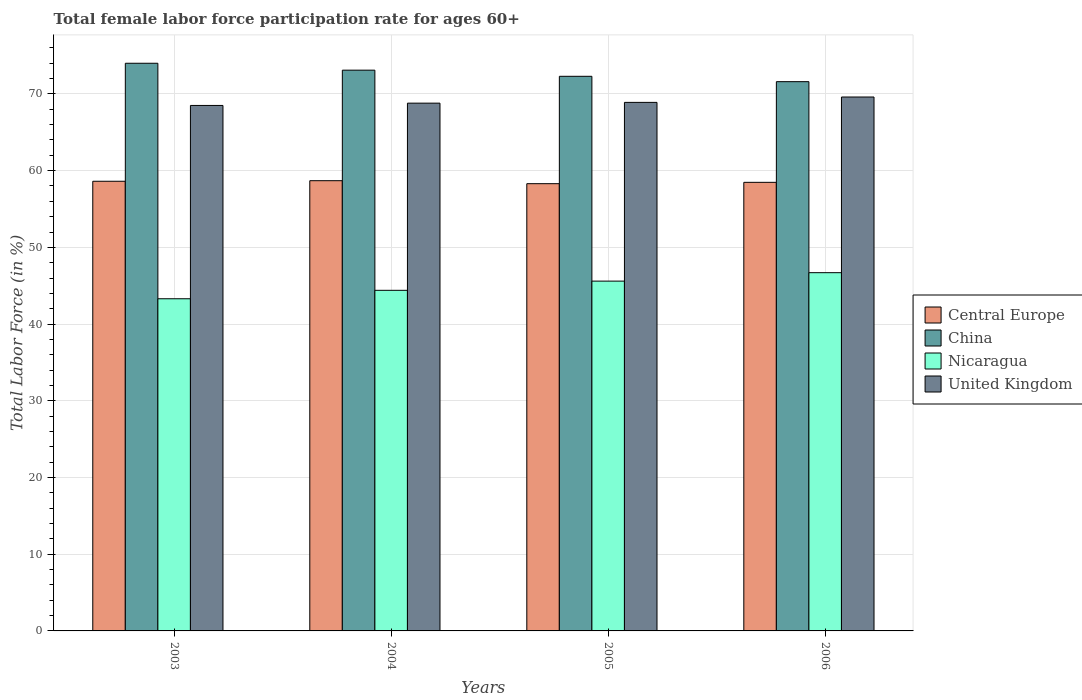How many bars are there on the 2nd tick from the left?
Keep it short and to the point. 4. How many bars are there on the 2nd tick from the right?
Provide a short and direct response. 4. In how many cases, is the number of bars for a given year not equal to the number of legend labels?
Your answer should be very brief. 0. What is the female labor force participation rate in Central Europe in 2004?
Keep it short and to the point. 58.69. Across all years, what is the maximum female labor force participation rate in United Kingdom?
Give a very brief answer. 69.6. Across all years, what is the minimum female labor force participation rate in China?
Offer a very short reply. 71.6. What is the total female labor force participation rate in Central Europe in the graph?
Make the answer very short. 234.09. What is the difference between the female labor force participation rate in United Kingdom in 2003 and that in 2005?
Make the answer very short. -0.4. What is the difference between the female labor force participation rate in Nicaragua in 2003 and the female labor force participation rate in China in 2006?
Ensure brevity in your answer.  -28.3. What is the average female labor force participation rate in Central Europe per year?
Provide a succinct answer. 58.52. In the year 2003, what is the difference between the female labor force participation rate in Central Europe and female labor force participation rate in Nicaragua?
Make the answer very short. 15.32. In how many years, is the female labor force participation rate in China greater than 66 %?
Ensure brevity in your answer.  4. What is the ratio of the female labor force participation rate in Nicaragua in 2004 to that in 2005?
Offer a very short reply. 0.97. Is the difference between the female labor force participation rate in Central Europe in 2005 and 2006 greater than the difference between the female labor force participation rate in Nicaragua in 2005 and 2006?
Give a very brief answer. Yes. What is the difference between the highest and the second highest female labor force participation rate in Central Europe?
Provide a short and direct response. 0.07. What is the difference between the highest and the lowest female labor force participation rate in Nicaragua?
Offer a terse response. 3.4. In how many years, is the female labor force participation rate in Nicaragua greater than the average female labor force participation rate in Nicaragua taken over all years?
Make the answer very short. 2. Is the sum of the female labor force participation rate in United Kingdom in 2003 and 2004 greater than the maximum female labor force participation rate in China across all years?
Keep it short and to the point. Yes. Is it the case that in every year, the sum of the female labor force participation rate in United Kingdom and female labor force participation rate in China is greater than the sum of female labor force participation rate in Nicaragua and female labor force participation rate in Central Europe?
Give a very brief answer. Yes. What does the 2nd bar from the right in 2005 represents?
Your answer should be very brief. Nicaragua. How many bars are there?
Give a very brief answer. 16. Are all the bars in the graph horizontal?
Your answer should be compact. No. How many years are there in the graph?
Your answer should be very brief. 4. Does the graph contain grids?
Make the answer very short. Yes. How many legend labels are there?
Offer a terse response. 4. What is the title of the graph?
Provide a short and direct response. Total female labor force participation rate for ages 60+. What is the label or title of the Y-axis?
Give a very brief answer. Total Labor Force (in %). What is the Total Labor Force (in %) of Central Europe in 2003?
Your answer should be compact. 58.62. What is the Total Labor Force (in %) in China in 2003?
Make the answer very short. 74. What is the Total Labor Force (in %) in Nicaragua in 2003?
Provide a short and direct response. 43.3. What is the Total Labor Force (in %) of United Kingdom in 2003?
Keep it short and to the point. 68.5. What is the Total Labor Force (in %) in Central Europe in 2004?
Provide a succinct answer. 58.69. What is the Total Labor Force (in %) of China in 2004?
Offer a very short reply. 73.1. What is the Total Labor Force (in %) in Nicaragua in 2004?
Provide a succinct answer. 44.4. What is the Total Labor Force (in %) of United Kingdom in 2004?
Your response must be concise. 68.8. What is the Total Labor Force (in %) in Central Europe in 2005?
Your response must be concise. 58.3. What is the Total Labor Force (in %) of China in 2005?
Your answer should be compact. 72.3. What is the Total Labor Force (in %) in Nicaragua in 2005?
Provide a succinct answer. 45.6. What is the Total Labor Force (in %) in United Kingdom in 2005?
Your answer should be compact. 68.9. What is the Total Labor Force (in %) in Central Europe in 2006?
Your response must be concise. 58.48. What is the Total Labor Force (in %) of China in 2006?
Ensure brevity in your answer.  71.6. What is the Total Labor Force (in %) of Nicaragua in 2006?
Your answer should be compact. 46.7. What is the Total Labor Force (in %) in United Kingdom in 2006?
Ensure brevity in your answer.  69.6. Across all years, what is the maximum Total Labor Force (in %) in Central Europe?
Your answer should be compact. 58.69. Across all years, what is the maximum Total Labor Force (in %) of China?
Offer a terse response. 74. Across all years, what is the maximum Total Labor Force (in %) in Nicaragua?
Your answer should be compact. 46.7. Across all years, what is the maximum Total Labor Force (in %) of United Kingdom?
Provide a succinct answer. 69.6. Across all years, what is the minimum Total Labor Force (in %) in Central Europe?
Keep it short and to the point. 58.3. Across all years, what is the minimum Total Labor Force (in %) in China?
Offer a very short reply. 71.6. Across all years, what is the minimum Total Labor Force (in %) of Nicaragua?
Ensure brevity in your answer.  43.3. Across all years, what is the minimum Total Labor Force (in %) in United Kingdom?
Offer a very short reply. 68.5. What is the total Total Labor Force (in %) of Central Europe in the graph?
Give a very brief answer. 234.09. What is the total Total Labor Force (in %) of China in the graph?
Offer a terse response. 291. What is the total Total Labor Force (in %) of Nicaragua in the graph?
Your answer should be very brief. 180. What is the total Total Labor Force (in %) of United Kingdom in the graph?
Ensure brevity in your answer.  275.8. What is the difference between the Total Labor Force (in %) of Central Europe in 2003 and that in 2004?
Offer a very short reply. -0.07. What is the difference between the Total Labor Force (in %) of China in 2003 and that in 2004?
Your response must be concise. 0.9. What is the difference between the Total Labor Force (in %) of Nicaragua in 2003 and that in 2004?
Give a very brief answer. -1.1. What is the difference between the Total Labor Force (in %) in United Kingdom in 2003 and that in 2004?
Ensure brevity in your answer.  -0.3. What is the difference between the Total Labor Force (in %) of Central Europe in 2003 and that in 2005?
Offer a very short reply. 0.32. What is the difference between the Total Labor Force (in %) in China in 2003 and that in 2005?
Provide a succinct answer. 1.7. What is the difference between the Total Labor Force (in %) in United Kingdom in 2003 and that in 2005?
Offer a terse response. -0.4. What is the difference between the Total Labor Force (in %) in Central Europe in 2003 and that in 2006?
Your answer should be very brief. 0.14. What is the difference between the Total Labor Force (in %) in China in 2003 and that in 2006?
Ensure brevity in your answer.  2.4. What is the difference between the Total Labor Force (in %) of Nicaragua in 2003 and that in 2006?
Provide a succinct answer. -3.4. What is the difference between the Total Labor Force (in %) of Central Europe in 2004 and that in 2005?
Offer a terse response. 0.39. What is the difference between the Total Labor Force (in %) of United Kingdom in 2004 and that in 2005?
Your response must be concise. -0.1. What is the difference between the Total Labor Force (in %) in Central Europe in 2004 and that in 2006?
Provide a succinct answer. 0.21. What is the difference between the Total Labor Force (in %) of Nicaragua in 2004 and that in 2006?
Offer a very short reply. -2.3. What is the difference between the Total Labor Force (in %) in United Kingdom in 2004 and that in 2006?
Offer a terse response. -0.8. What is the difference between the Total Labor Force (in %) of Central Europe in 2005 and that in 2006?
Ensure brevity in your answer.  -0.18. What is the difference between the Total Labor Force (in %) in China in 2005 and that in 2006?
Offer a very short reply. 0.7. What is the difference between the Total Labor Force (in %) of United Kingdom in 2005 and that in 2006?
Your answer should be very brief. -0.7. What is the difference between the Total Labor Force (in %) of Central Europe in 2003 and the Total Labor Force (in %) of China in 2004?
Offer a terse response. -14.48. What is the difference between the Total Labor Force (in %) of Central Europe in 2003 and the Total Labor Force (in %) of Nicaragua in 2004?
Ensure brevity in your answer.  14.22. What is the difference between the Total Labor Force (in %) of Central Europe in 2003 and the Total Labor Force (in %) of United Kingdom in 2004?
Offer a very short reply. -10.18. What is the difference between the Total Labor Force (in %) in China in 2003 and the Total Labor Force (in %) in Nicaragua in 2004?
Give a very brief answer. 29.6. What is the difference between the Total Labor Force (in %) in China in 2003 and the Total Labor Force (in %) in United Kingdom in 2004?
Keep it short and to the point. 5.2. What is the difference between the Total Labor Force (in %) of Nicaragua in 2003 and the Total Labor Force (in %) of United Kingdom in 2004?
Provide a short and direct response. -25.5. What is the difference between the Total Labor Force (in %) in Central Europe in 2003 and the Total Labor Force (in %) in China in 2005?
Your response must be concise. -13.68. What is the difference between the Total Labor Force (in %) of Central Europe in 2003 and the Total Labor Force (in %) of Nicaragua in 2005?
Give a very brief answer. 13.02. What is the difference between the Total Labor Force (in %) in Central Europe in 2003 and the Total Labor Force (in %) in United Kingdom in 2005?
Provide a short and direct response. -10.28. What is the difference between the Total Labor Force (in %) of China in 2003 and the Total Labor Force (in %) of Nicaragua in 2005?
Your answer should be compact. 28.4. What is the difference between the Total Labor Force (in %) of China in 2003 and the Total Labor Force (in %) of United Kingdom in 2005?
Your answer should be compact. 5.1. What is the difference between the Total Labor Force (in %) of Nicaragua in 2003 and the Total Labor Force (in %) of United Kingdom in 2005?
Ensure brevity in your answer.  -25.6. What is the difference between the Total Labor Force (in %) in Central Europe in 2003 and the Total Labor Force (in %) in China in 2006?
Ensure brevity in your answer.  -12.98. What is the difference between the Total Labor Force (in %) in Central Europe in 2003 and the Total Labor Force (in %) in Nicaragua in 2006?
Offer a terse response. 11.92. What is the difference between the Total Labor Force (in %) of Central Europe in 2003 and the Total Labor Force (in %) of United Kingdom in 2006?
Provide a short and direct response. -10.98. What is the difference between the Total Labor Force (in %) in China in 2003 and the Total Labor Force (in %) in Nicaragua in 2006?
Give a very brief answer. 27.3. What is the difference between the Total Labor Force (in %) of China in 2003 and the Total Labor Force (in %) of United Kingdom in 2006?
Your response must be concise. 4.4. What is the difference between the Total Labor Force (in %) in Nicaragua in 2003 and the Total Labor Force (in %) in United Kingdom in 2006?
Provide a short and direct response. -26.3. What is the difference between the Total Labor Force (in %) of Central Europe in 2004 and the Total Labor Force (in %) of China in 2005?
Make the answer very short. -13.61. What is the difference between the Total Labor Force (in %) of Central Europe in 2004 and the Total Labor Force (in %) of Nicaragua in 2005?
Your answer should be compact. 13.09. What is the difference between the Total Labor Force (in %) in Central Europe in 2004 and the Total Labor Force (in %) in United Kingdom in 2005?
Give a very brief answer. -10.21. What is the difference between the Total Labor Force (in %) in China in 2004 and the Total Labor Force (in %) in Nicaragua in 2005?
Provide a succinct answer. 27.5. What is the difference between the Total Labor Force (in %) in Nicaragua in 2004 and the Total Labor Force (in %) in United Kingdom in 2005?
Your answer should be very brief. -24.5. What is the difference between the Total Labor Force (in %) of Central Europe in 2004 and the Total Labor Force (in %) of China in 2006?
Ensure brevity in your answer.  -12.91. What is the difference between the Total Labor Force (in %) in Central Europe in 2004 and the Total Labor Force (in %) in Nicaragua in 2006?
Offer a terse response. 11.99. What is the difference between the Total Labor Force (in %) in Central Europe in 2004 and the Total Labor Force (in %) in United Kingdom in 2006?
Offer a very short reply. -10.91. What is the difference between the Total Labor Force (in %) of China in 2004 and the Total Labor Force (in %) of Nicaragua in 2006?
Offer a terse response. 26.4. What is the difference between the Total Labor Force (in %) of China in 2004 and the Total Labor Force (in %) of United Kingdom in 2006?
Make the answer very short. 3.5. What is the difference between the Total Labor Force (in %) in Nicaragua in 2004 and the Total Labor Force (in %) in United Kingdom in 2006?
Offer a terse response. -25.2. What is the difference between the Total Labor Force (in %) of Central Europe in 2005 and the Total Labor Force (in %) of China in 2006?
Offer a very short reply. -13.3. What is the difference between the Total Labor Force (in %) in Central Europe in 2005 and the Total Labor Force (in %) in Nicaragua in 2006?
Your answer should be very brief. 11.6. What is the difference between the Total Labor Force (in %) in Central Europe in 2005 and the Total Labor Force (in %) in United Kingdom in 2006?
Give a very brief answer. -11.3. What is the difference between the Total Labor Force (in %) in China in 2005 and the Total Labor Force (in %) in Nicaragua in 2006?
Provide a short and direct response. 25.6. What is the difference between the Total Labor Force (in %) of China in 2005 and the Total Labor Force (in %) of United Kingdom in 2006?
Make the answer very short. 2.7. What is the difference between the Total Labor Force (in %) in Nicaragua in 2005 and the Total Labor Force (in %) in United Kingdom in 2006?
Provide a short and direct response. -24. What is the average Total Labor Force (in %) of Central Europe per year?
Your response must be concise. 58.52. What is the average Total Labor Force (in %) of China per year?
Offer a terse response. 72.75. What is the average Total Labor Force (in %) in United Kingdom per year?
Your response must be concise. 68.95. In the year 2003, what is the difference between the Total Labor Force (in %) of Central Europe and Total Labor Force (in %) of China?
Make the answer very short. -15.38. In the year 2003, what is the difference between the Total Labor Force (in %) in Central Europe and Total Labor Force (in %) in Nicaragua?
Keep it short and to the point. 15.32. In the year 2003, what is the difference between the Total Labor Force (in %) in Central Europe and Total Labor Force (in %) in United Kingdom?
Offer a terse response. -9.88. In the year 2003, what is the difference between the Total Labor Force (in %) in China and Total Labor Force (in %) in Nicaragua?
Keep it short and to the point. 30.7. In the year 2003, what is the difference between the Total Labor Force (in %) in Nicaragua and Total Labor Force (in %) in United Kingdom?
Give a very brief answer. -25.2. In the year 2004, what is the difference between the Total Labor Force (in %) of Central Europe and Total Labor Force (in %) of China?
Your response must be concise. -14.41. In the year 2004, what is the difference between the Total Labor Force (in %) of Central Europe and Total Labor Force (in %) of Nicaragua?
Provide a succinct answer. 14.29. In the year 2004, what is the difference between the Total Labor Force (in %) of Central Europe and Total Labor Force (in %) of United Kingdom?
Provide a succinct answer. -10.11. In the year 2004, what is the difference between the Total Labor Force (in %) in China and Total Labor Force (in %) in Nicaragua?
Ensure brevity in your answer.  28.7. In the year 2004, what is the difference between the Total Labor Force (in %) of China and Total Labor Force (in %) of United Kingdom?
Provide a short and direct response. 4.3. In the year 2004, what is the difference between the Total Labor Force (in %) of Nicaragua and Total Labor Force (in %) of United Kingdom?
Provide a short and direct response. -24.4. In the year 2005, what is the difference between the Total Labor Force (in %) of Central Europe and Total Labor Force (in %) of China?
Your answer should be compact. -14. In the year 2005, what is the difference between the Total Labor Force (in %) in Central Europe and Total Labor Force (in %) in Nicaragua?
Your answer should be very brief. 12.7. In the year 2005, what is the difference between the Total Labor Force (in %) of Central Europe and Total Labor Force (in %) of United Kingdom?
Your answer should be very brief. -10.6. In the year 2005, what is the difference between the Total Labor Force (in %) of China and Total Labor Force (in %) of Nicaragua?
Provide a short and direct response. 26.7. In the year 2005, what is the difference between the Total Labor Force (in %) of Nicaragua and Total Labor Force (in %) of United Kingdom?
Ensure brevity in your answer.  -23.3. In the year 2006, what is the difference between the Total Labor Force (in %) of Central Europe and Total Labor Force (in %) of China?
Provide a short and direct response. -13.12. In the year 2006, what is the difference between the Total Labor Force (in %) of Central Europe and Total Labor Force (in %) of Nicaragua?
Provide a short and direct response. 11.78. In the year 2006, what is the difference between the Total Labor Force (in %) in Central Europe and Total Labor Force (in %) in United Kingdom?
Provide a succinct answer. -11.12. In the year 2006, what is the difference between the Total Labor Force (in %) in China and Total Labor Force (in %) in Nicaragua?
Your answer should be very brief. 24.9. In the year 2006, what is the difference between the Total Labor Force (in %) in China and Total Labor Force (in %) in United Kingdom?
Give a very brief answer. 2. In the year 2006, what is the difference between the Total Labor Force (in %) in Nicaragua and Total Labor Force (in %) in United Kingdom?
Give a very brief answer. -22.9. What is the ratio of the Total Labor Force (in %) in China in 2003 to that in 2004?
Offer a terse response. 1.01. What is the ratio of the Total Labor Force (in %) in Nicaragua in 2003 to that in 2004?
Your response must be concise. 0.98. What is the ratio of the Total Labor Force (in %) of Central Europe in 2003 to that in 2005?
Give a very brief answer. 1.01. What is the ratio of the Total Labor Force (in %) in China in 2003 to that in 2005?
Keep it short and to the point. 1.02. What is the ratio of the Total Labor Force (in %) of Nicaragua in 2003 to that in 2005?
Offer a very short reply. 0.95. What is the ratio of the Total Labor Force (in %) in United Kingdom in 2003 to that in 2005?
Provide a succinct answer. 0.99. What is the ratio of the Total Labor Force (in %) in Central Europe in 2003 to that in 2006?
Your answer should be compact. 1. What is the ratio of the Total Labor Force (in %) in China in 2003 to that in 2006?
Your answer should be compact. 1.03. What is the ratio of the Total Labor Force (in %) in Nicaragua in 2003 to that in 2006?
Your response must be concise. 0.93. What is the ratio of the Total Labor Force (in %) of United Kingdom in 2003 to that in 2006?
Make the answer very short. 0.98. What is the ratio of the Total Labor Force (in %) in China in 2004 to that in 2005?
Provide a short and direct response. 1.01. What is the ratio of the Total Labor Force (in %) of Nicaragua in 2004 to that in 2005?
Provide a short and direct response. 0.97. What is the ratio of the Total Labor Force (in %) in United Kingdom in 2004 to that in 2005?
Offer a very short reply. 1. What is the ratio of the Total Labor Force (in %) in Central Europe in 2004 to that in 2006?
Give a very brief answer. 1. What is the ratio of the Total Labor Force (in %) in China in 2004 to that in 2006?
Ensure brevity in your answer.  1.02. What is the ratio of the Total Labor Force (in %) of Nicaragua in 2004 to that in 2006?
Offer a terse response. 0.95. What is the ratio of the Total Labor Force (in %) of China in 2005 to that in 2006?
Offer a very short reply. 1.01. What is the ratio of the Total Labor Force (in %) of Nicaragua in 2005 to that in 2006?
Your answer should be very brief. 0.98. What is the difference between the highest and the second highest Total Labor Force (in %) in Central Europe?
Your answer should be very brief. 0.07. What is the difference between the highest and the second highest Total Labor Force (in %) of Nicaragua?
Provide a short and direct response. 1.1. What is the difference between the highest and the second highest Total Labor Force (in %) in United Kingdom?
Make the answer very short. 0.7. What is the difference between the highest and the lowest Total Labor Force (in %) of Central Europe?
Provide a succinct answer. 0.39. What is the difference between the highest and the lowest Total Labor Force (in %) of Nicaragua?
Offer a very short reply. 3.4. 